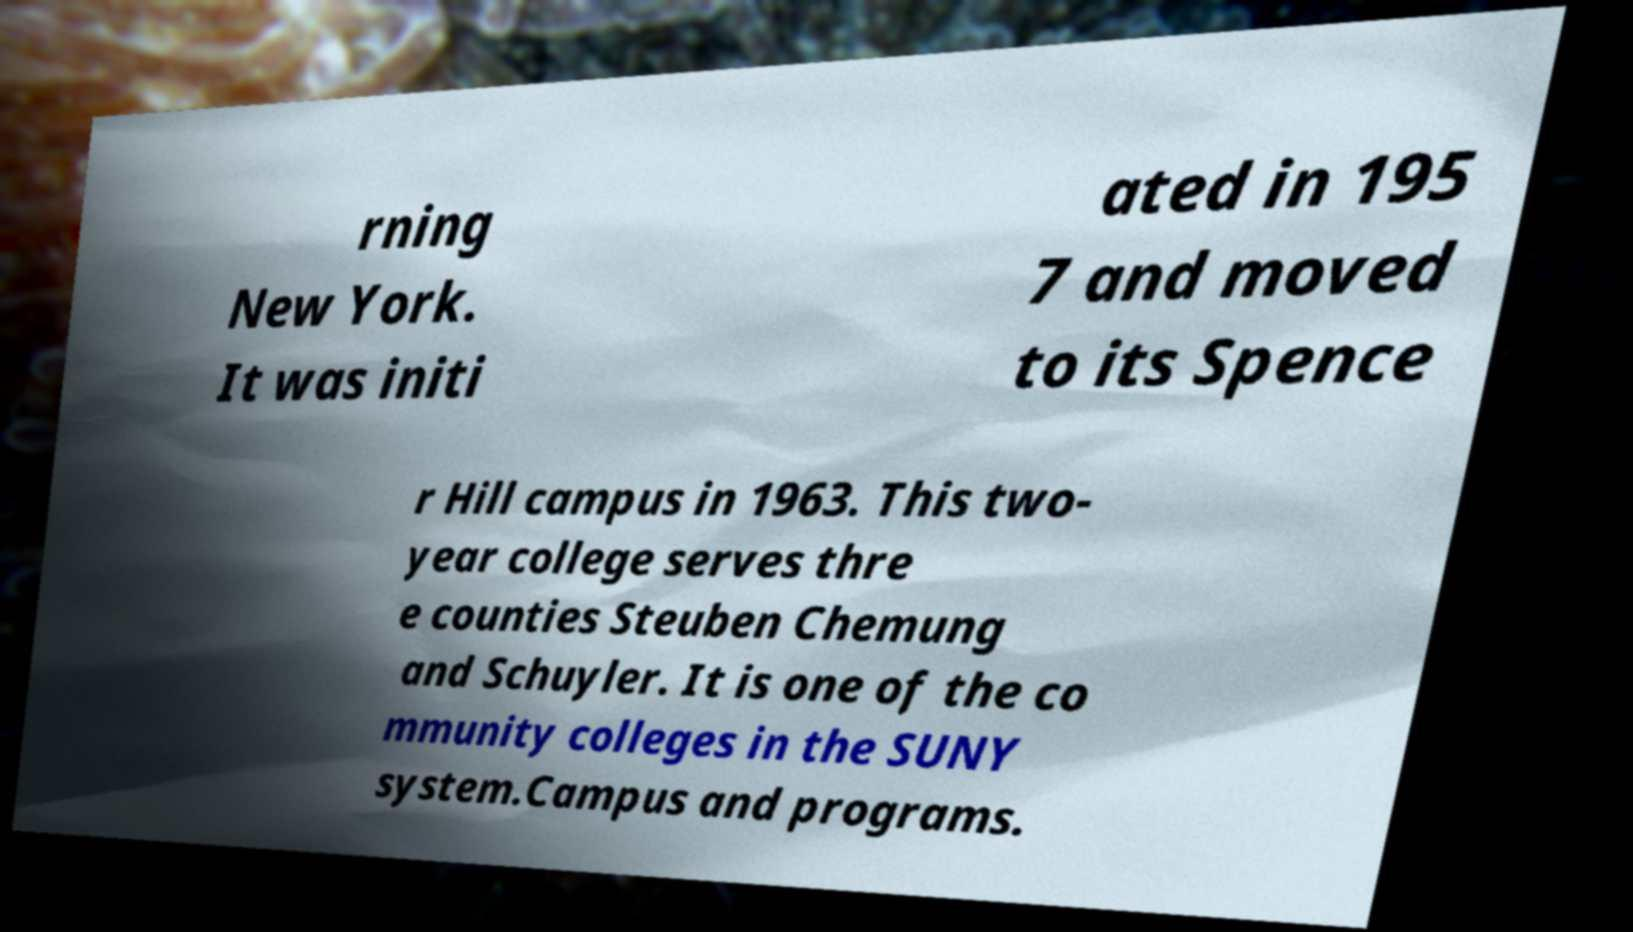Can you accurately transcribe the text from the provided image for me? rning New York. It was initi ated in 195 7 and moved to its Spence r Hill campus in 1963. This two- year college serves thre e counties Steuben Chemung and Schuyler. It is one of the co mmunity colleges in the SUNY system.Campus and programs. 